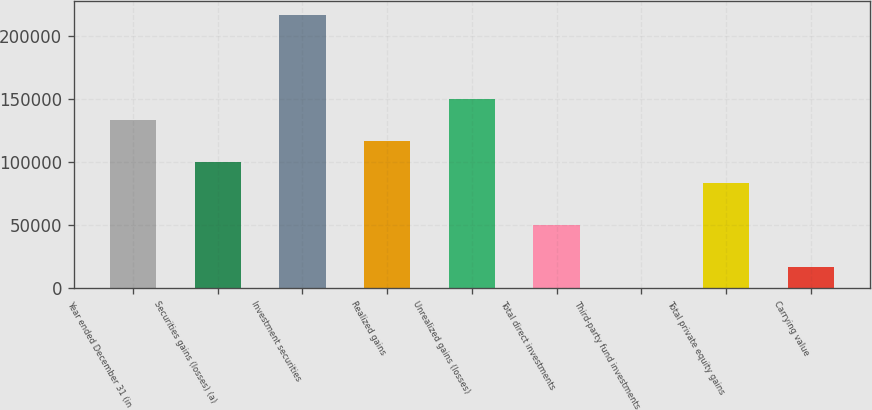<chart> <loc_0><loc_0><loc_500><loc_500><bar_chart><fcel>Year ended December 31 (in<fcel>Securities gains (losses) (a)<fcel>Investment securities<fcel>Realized gains<fcel>Unrealized gains (losses)<fcel>Total direct investments<fcel>Third-party fund investments<fcel>Total private equity gains<fcel>Carrying value<nl><fcel>133356<fcel>100050<fcel>216621<fcel>116703<fcel>150009<fcel>50090.3<fcel>131<fcel>83396.5<fcel>16784.1<nl></chart> 